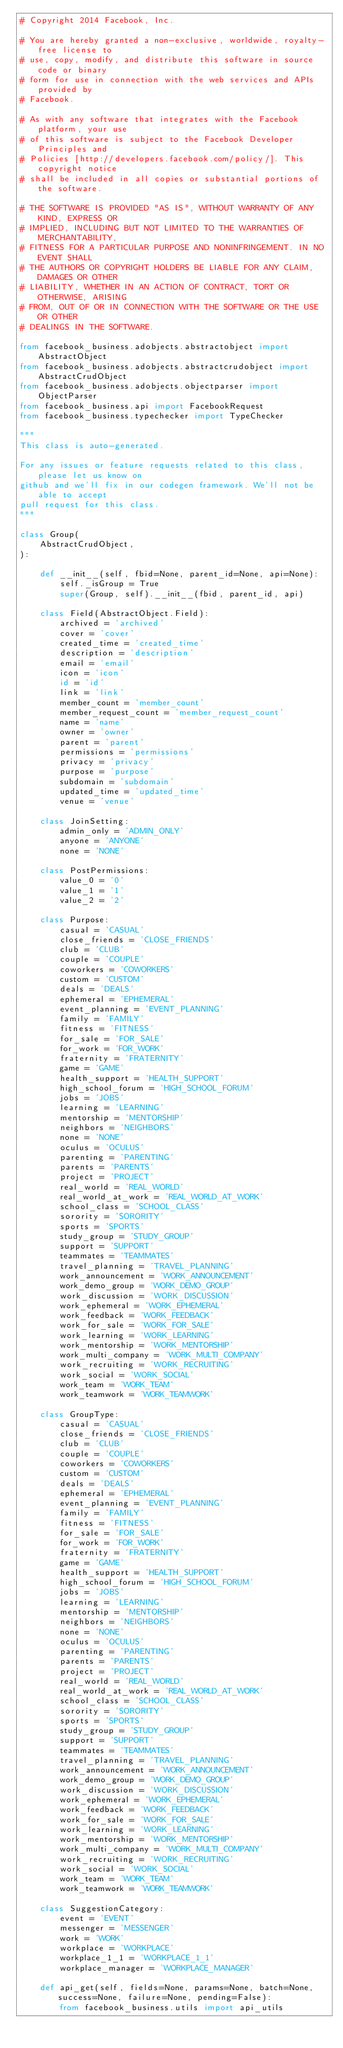<code> <loc_0><loc_0><loc_500><loc_500><_Python_># Copyright 2014 Facebook, Inc.

# You are hereby granted a non-exclusive, worldwide, royalty-free license to
# use, copy, modify, and distribute this software in source code or binary
# form for use in connection with the web services and APIs provided by
# Facebook.

# As with any software that integrates with the Facebook platform, your use
# of this software is subject to the Facebook Developer Principles and
# Policies [http://developers.facebook.com/policy/]. This copyright notice
# shall be included in all copies or substantial portions of the software.

# THE SOFTWARE IS PROVIDED "AS IS", WITHOUT WARRANTY OF ANY KIND, EXPRESS OR
# IMPLIED, INCLUDING BUT NOT LIMITED TO THE WARRANTIES OF MERCHANTABILITY,
# FITNESS FOR A PARTICULAR PURPOSE AND NONINFRINGEMENT. IN NO EVENT SHALL
# THE AUTHORS OR COPYRIGHT HOLDERS BE LIABLE FOR ANY CLAIM, DAMAGES OR OTHER
# LIABILITY, WHETHER IN AN ACTION OF CONTRACT, TORT OR OTHERWISE, ARISING
# FROM, OUT OF OR IN CONNECTION WITH THE SOFTWARE OR THE USE OR OTHER
# DEALINGS IN THE SOFTWARE.

from facebook_business.adobjects.abstractobject import AbstractObject
from facebook_business.adobjects.abstractcrudobject import AbstractCrudObject
from facebook_business.adobjects.objectparser import ObjectParser
from facebook_business.api import FacebookRequest
from facebook_business.typechecker import TypeChecker

"""
This class is auto-generated.

For any issues or feature requests related to this class, please let us know on
github and we'll fix in our codegen framework. We'll not be able to accept
pull request for this class.
"""

class Group(
    AbstractCrudObject,
):

    def __init__(self, fbid=None, parent_id=None, api=None):
        self._isGroup = True
        super(Group, self).__init__(fbid, parent_id, api)

    class Field(AbstractObject.Field):
        archived = 'archived'
        cover = 'cover'
        created_time = 'created_time'
        description = 'description'
        email = 'email'
        icon = 'icon'
        id = 'id'
        link = 'link'
        member_count = 'member_count'
        member_request_count = 'member_request_count'
        name = 'name'
        owner = 'owner'
        parent = 'parent'
        permissions = 'permissions'
        privacy = 'privacy'
        purpose = 'purpose'
        subdomain = 'subdomain'
        updated_time = 'updated_time'
        venue = 'venue'

    class JoinSetting:
        admin_only = 'ADMIN_ONLY'
        anyone = 'ANYONE'
        none = 'NONE'

    class PostPermissions:
        value_0 = '0'
        value_1 = '1'
        value_2 = '2'

    class Purpose:
        casual = 'CASUAL'
        close_friends = 'CLOSE_FRIENDS'
        club = 'CLUB'
        couple = 'COUPLE'
        coworkers = 'COWORKERS'
        custom = 'CUSTOM'
        deals = 'DEALS'
        ephemeral = 'EPHEMERAL'
        event_planning = 'EVENT_PLANNING'
        family = 'FAMILY'
        fitness = 'FITNESS'
        for_sale = 'FOR_SALE'
        for_work = 'FOR_WORK'
        fraternity = 'FRATERNITY'
        game = 'GAME'
        health_support = 'HEALTH_SUPPORT'
        high_school_forum = 'HIGH_SCHOOL_FORUM'
        jobs = 'JOBS'
        learning = 'LEARNING'
        mentorship = 'MENTORSHIP'
        neighbors = 'NEIGHBORS'
        none = 'NONE'
        oculus = 'OCULUS'
        parenting = 'PARENTING'
        parents = 'PARENTS'
        project = 'PROJECT'
        real_world = 'REAL_WORLD'
        real_world_at_work = 'REAL_WORLD_AT_WORK'
        school_class = 'SCHOOL_CLASS'
        sorority = 'SORORITY'
        sports = 'SPORTS'
        study_group = 'STUDY_GROUP'
        support = 'SUPPORT'
        teammates = 'TEAMMATES'
        travel_planning = 'TRAVEL_PLANNING'
        work_announcement = 'WORK_ANNOUNCEMENT'
        work_demo_group = 'WORK_DEMO_GROUP'
        work_discussion = 'WORK_DISCUSSION'
        work_ephemeral = 'WORK_EPHEMERAL'
        work_feedback = 'WORK_FEEDBACK'
        work_for_sale = 'WORK_FOR_SALE'
        work_learning = 'WORK_LEARNING'
        work_mentorship = 'WORK_MENTORSHIP'
        work_multi_company = 'WORK_MULTI_COMPANY'
        work_recruiting = 'WORK_RECRUITING'
        work_social = 'WORK_SOCIAL'
        work_team = 'WORK_TEAM'
        work_teamwork = 'WORK_TEAMWORK'

    class GroupType:
        casual = 'CASUAL'
        close_friends = 'CLOSE_FRIENDS'
        club = 'CLUB'
        couple = 'COUPLE'
        coworkers = 'COWORKERS'
        custom = 'CUSTOM'
        deals = 'DEALS'
        ephemeral = 'EPHEMERAL'
        event_planning = 'EVENT_PLANNING'
        family = 'FAMILY'
        fitness = 'FITNESS'
        for_sale = 'FOR_SALE'
        for_work = 'FOR_WORK'
        fraternity = 'FRATERNITY'
        game = 'GAME'
        health_support = 'HEALTH_SUPPORT'
        high_school_forum = 'HIGH_SCHOOL_FORUM'
        jobs = 'JOBS'
        learning = 'LEARNING'
        mentorship = 'MENTORSHIP'
        neighbors = 'NEIGHBORS'
        none = 'NONE'
        oculus = 'OCULUS'
        parenting = 'PARENTING'
        parents = 'PARENTS'
        project = 'PROJECT'
        real_world = 'REAL_WORLD'
        real_world_at_work = 'REAL_WORLD_AT_WORK'
        school_class = 'SCHOOL_CLASS'
        sorority = 'SORORITY'
        sports = 'SPORTS'
        study_group = 'STUDY_GROUP'
        support = 'SUPPORT'
        teammates = 'TEAMMATES'
        travel_planning = 'TRAVEL_PLANNING'
        work_announcement = 'WORK_ANNOUNCEMENT'
        work_demo_group = 'WORK_DEMO_GROUP'
        work_discussion = 'WORK_DISCUSSION'
        work_ephemeral = 'WORK_EPHEMERAL'
        work_feedback = 'WORK_FEEDBACK'
        work_for_sale = 'WORK_FOR_SALE'
        work_learning = 'WORK_LEARNING'
        work_mentorship = 'WORK_MENTORSHIP'
        work_multi_company = 'WORK_MULTI_COMPANY'
        work_recruiting = 'WORK_RECRUITING'
        work_social = 'WORK_SOCIAL'
        work_team = 'WORK_TEAM'
        work_teamwork = 'WORK_TEAMWORK'

    class SuggestionCategory:
        event = 'EVENT'
        messenger = 'MESSENGER'
        work = 'WORK'
        workplace = 'WORKPLACE'
        workplace_1_1 = 'WORKPLACE_1_1'
        workplace_manager = 'WORKPLACE_MANAGER'

    def api_get(self, fields=None, params=None, batch=None, success=None, failure=None, pending=False):
        from facebook_business.utils import api_utils</code> 